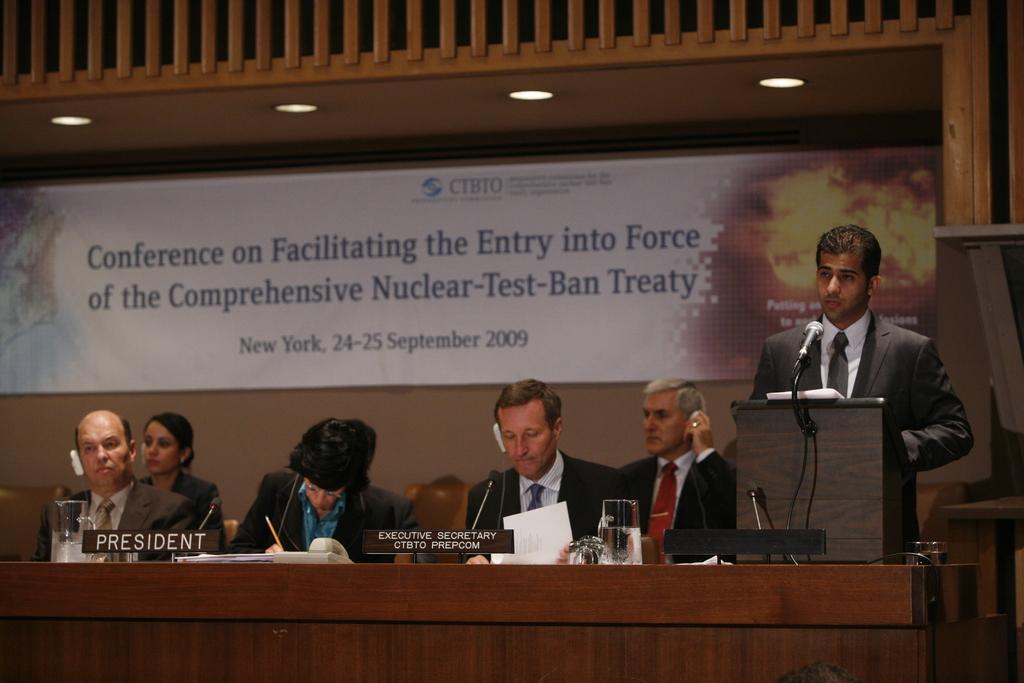How would you summarize this image in a sentence or two? In this picture I can see few people are sitting in front of the table and one person is standing and talking in front of the mike, on the table few objects placed. 